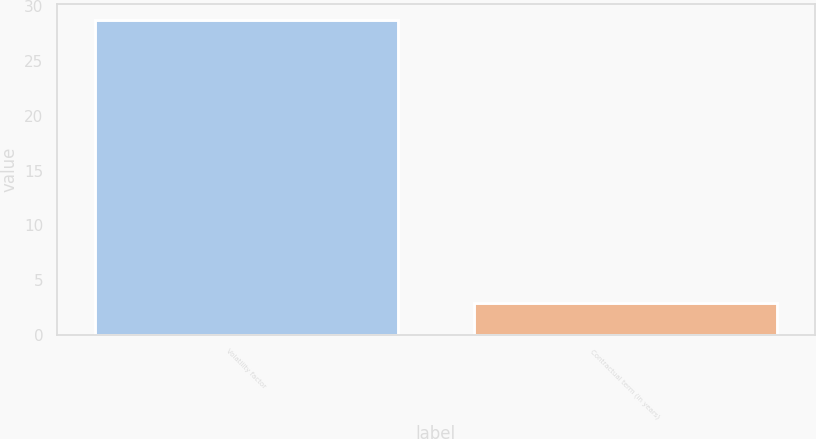<chart> <loc_0><loc_0><loc_500><loc_500><bar_chart><fcel>Volatility factor<fcel>Contractual term (in years)<nl><fcel>28.8<fcel>2.89<nl></chart> 